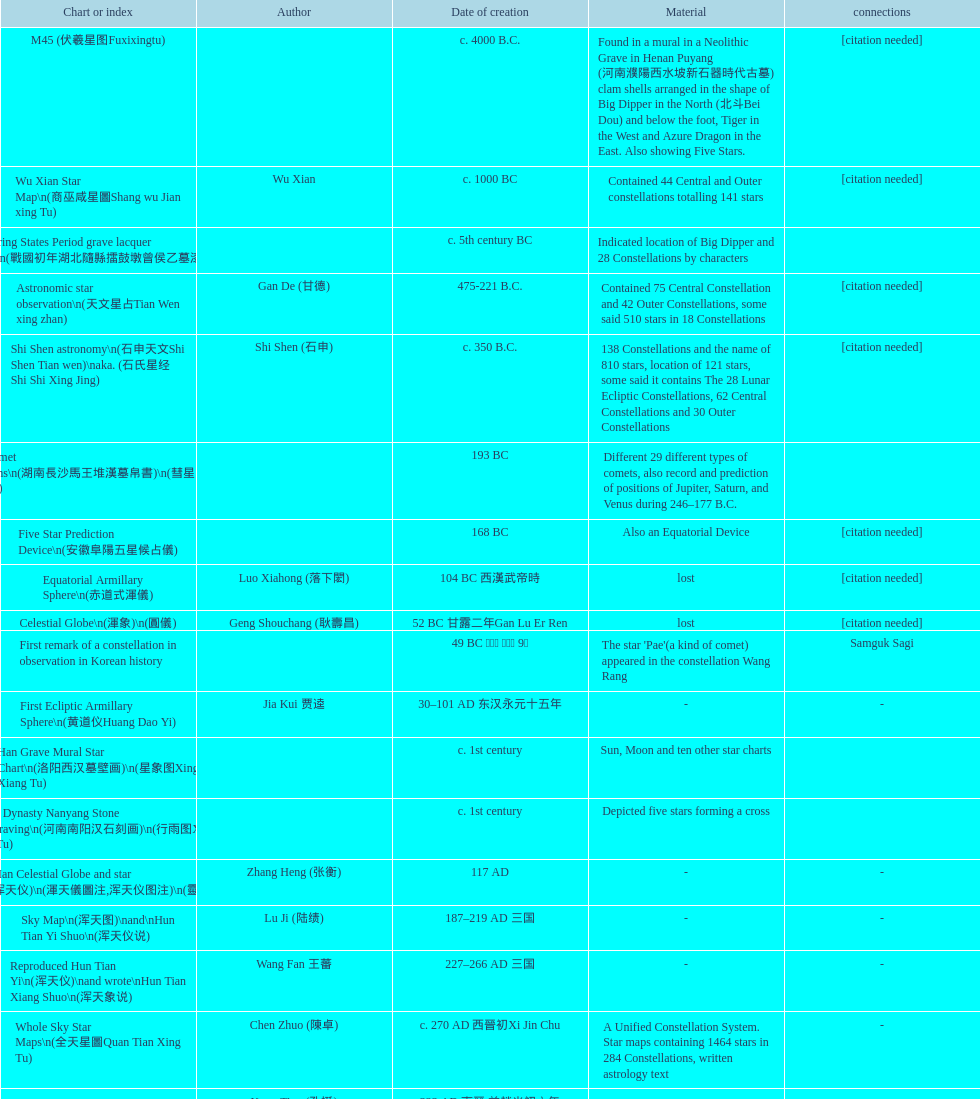Which was the first chinese star map known to have been created? M45 (伏羲星图Fuxixingtu). 